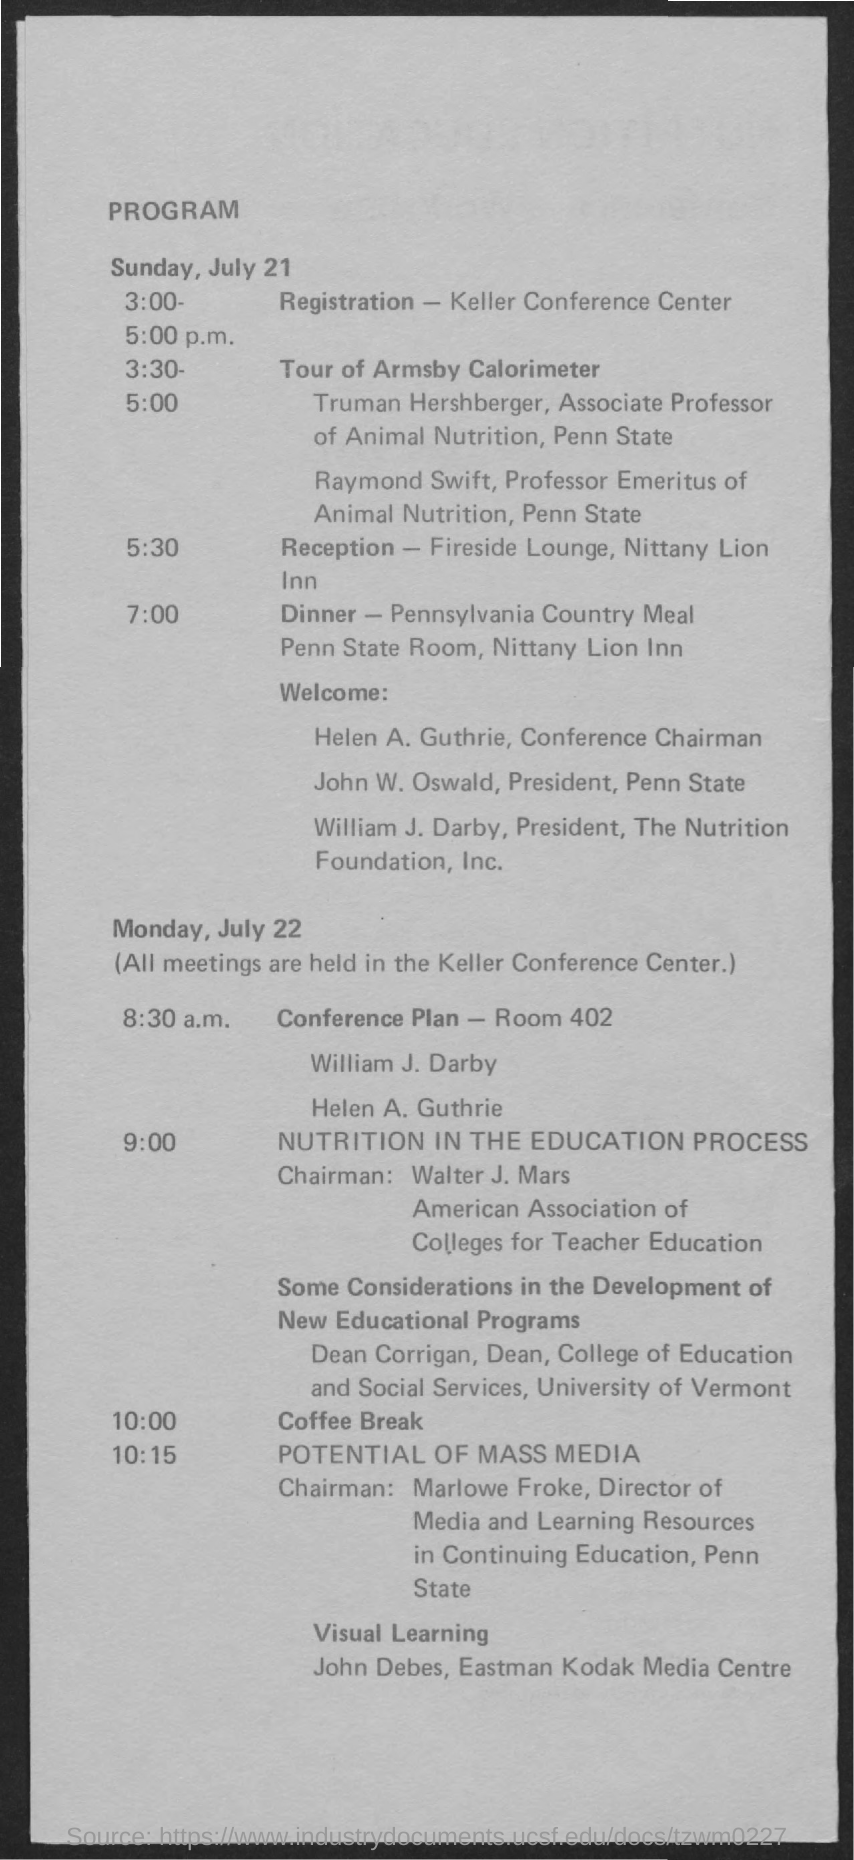Specify some key components in this picture. The reception will take place at 5:30 PM. The second date mentioned in the document is Monday, July 22. The title of the document is "Program. The first date mentioned in the document is July 21. The coffee break is scheduled for 10:00. 